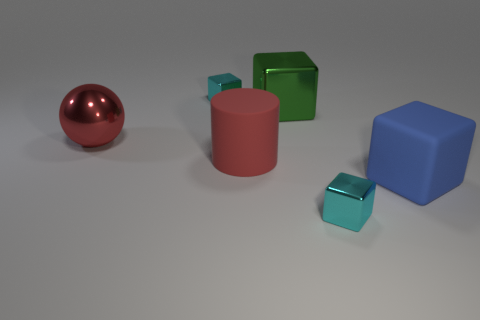If this image represented a simplified cityscape, what could each shape symbolize? If we interpret the image as a stylized cityscape, the large red sphere could represent a landmark or a central feature like a sculpture. The cylinders might be towers or cylindrical buildings, while the cubes could symbolize regular buildings. The varying sizes of the shapes could indicate different building functions or statuses, with the smaller, translucent cubes possibly representing parks or open spaces due to their airy appearance. 